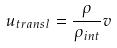Convert formula to latex. <formula><loc_0><loc_0><loc_500><loc_500>u _ { t r a n s l } = \frac { \rho } { \rho _ { i n t } } v</formula> 